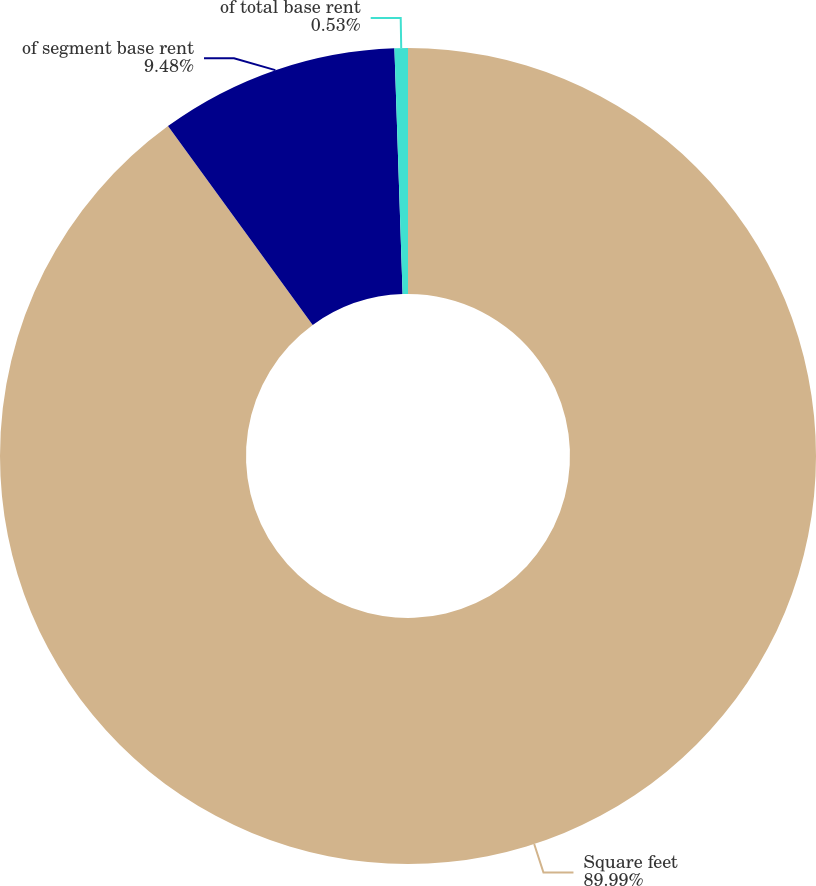<chart> <loc_0><loc_0><loc_500><loc_500><pie_chart><fcel>Square feet<fcel>of segment base rent<fcel>of total base rent<nl><fcel>90.0%<fcel>9.48%<fcel>0.53%<nl></chart> 